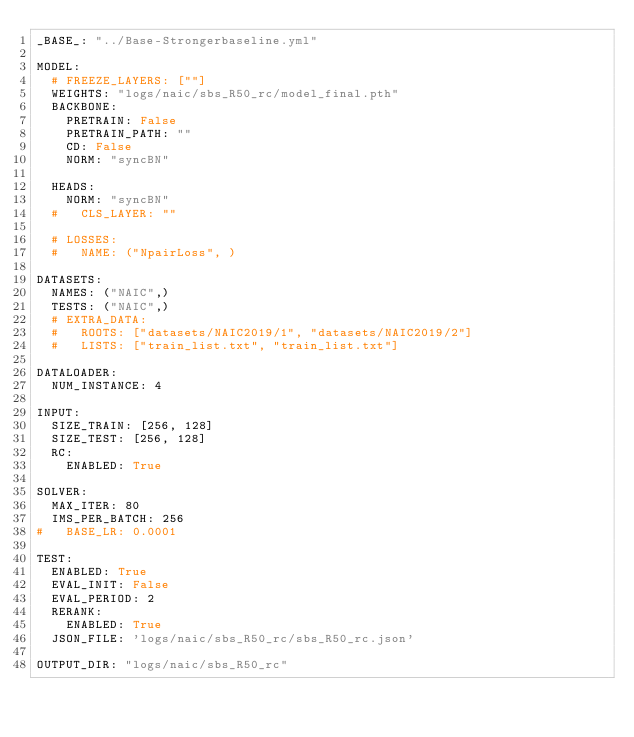Convert code to text. <code><loc_0><loc_0><loc_500><loc_500><_YAML_>_BASE_: "../Base-Strongerbaseline.yml"

MODEL:
  # FREEZE_LAYERS: [""]
  WEIGHTS: "logs/naic/sbs_R50_rc/model_final.pth"
  BACKBONE:
    PRETRAIN: False
    PRETRAIN_PATH: ""
    CD: False
    NORM: "syncBN"
  
  HEADS:
    NORM: "syncBN"
  #   CLS_LAYER: ""

  # LOSSES:
  #   NAME: ("NpairLoss", )

DATASETS:
  NAMES: ("NAIC",)
  TESTS: ("NAIC",)
  # EXTRA_DATA:
  #   ROOTS: ["datasets/NAIC2019/1", "datasets/NAIC2019/2"]
  #   LISTS: ["train_list.txt", "train_list.txt"]

DATALOADER:
  NUM_INSTANCE: 4

INPUT:
  SIZE_TRAIN: [256, 128]
  SIZE_TEST: [256, 128]
  RC:
    ENABLED: True

SOLVER:
  MAX_ITER: 80
  IMS_PER_BATCH: 256
#   BASE_LR: 0.0001

TEST:
  ENABLED: True
  EVAL_INIT: False
  EVAL_PERIOD: 2
  RERANK:
    ENABLED: True
  JSON_FILE: 'logs/naic/sbs_R50_rc/sbs_R50_rc.json'

OUTPUT_DIR: "logs/naic/sbs_R50_rc"
</code> 